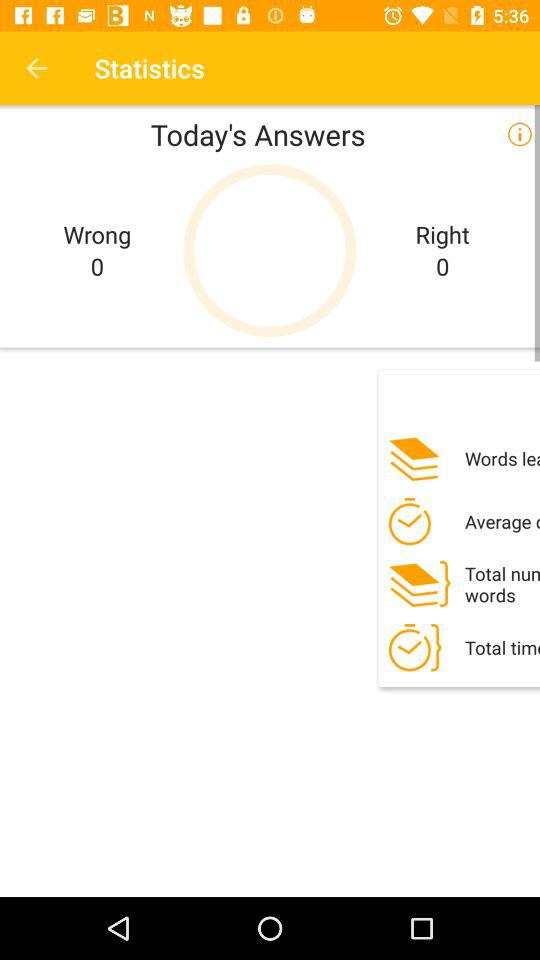What is the count of wrong answers? The count is 0. 